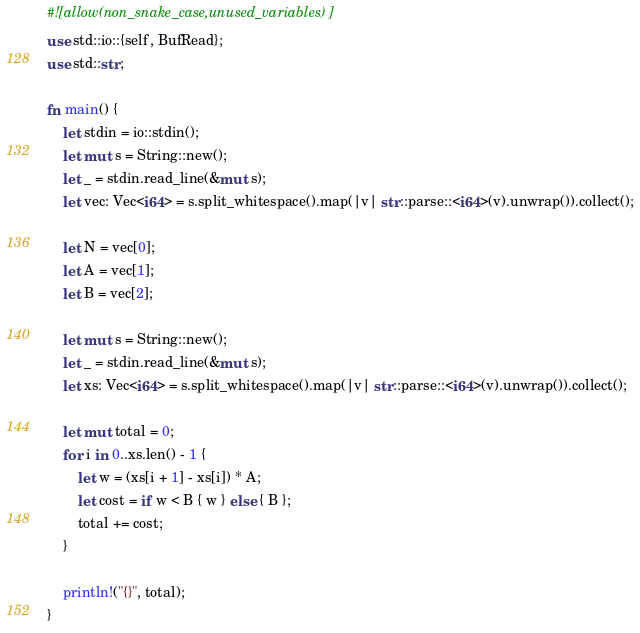<code> <loc_0><loc_0><loc_500><loc_500><_Rust_>#![allow(non_snake_case,unused_variables)]
use std::io::{self, BufRead};
use std::str;

fn main() {
    let stdin = io::stdin();
    let mut s = String::new();
    let _ = stdin.read_line(&mut s);
    let vec: Vec<i64> = s.split_whitespace().map(|v| str::parse::<i64>(v).unwrap()).collect();

    let N = vec[0];
    let A = vec[1];
    let B = vec[2];

    let mut s = String::new();
    let _ = stdin.read_line(&mut s);
    let xs: Vec<i64> = s.split_whitespace().map(|v| str::parse::<i64>(v).unwrap()).collect();

    let mut total = 0;
    for i in 0..xs.len() - 1 {
        let w = (xs[i + 1] - xs[i]) * A;
        let cost = if w < B { w } else { B };
        total += cost;
    }

    println!("{}", total);
}
</code> 